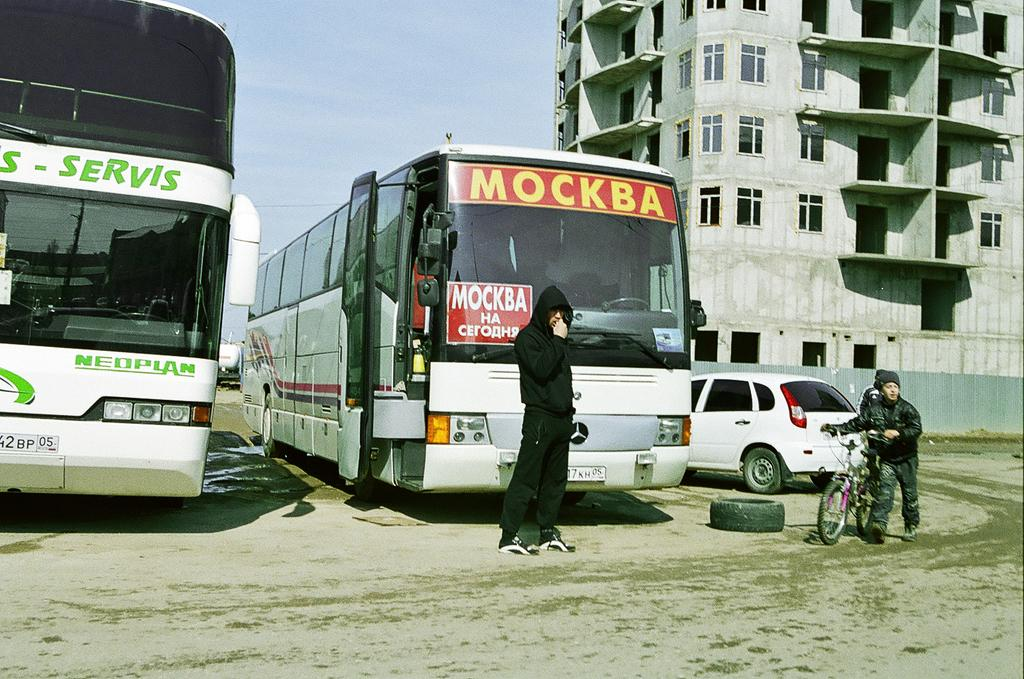<image>
Relay a brief, clear account of the picture shown. Two buses are parked  and one of them has the word Mockba on it. 